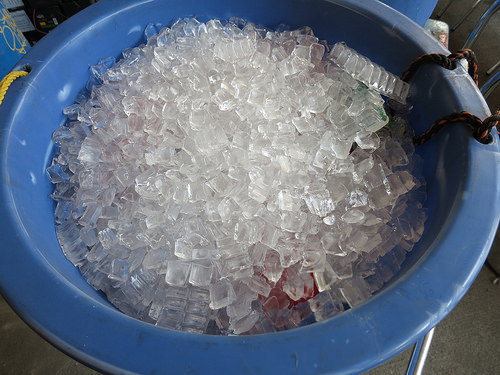<image>
Is the ice in the basket? No. The ice is not contained within the basket. These objects have a different spatial relationship. 